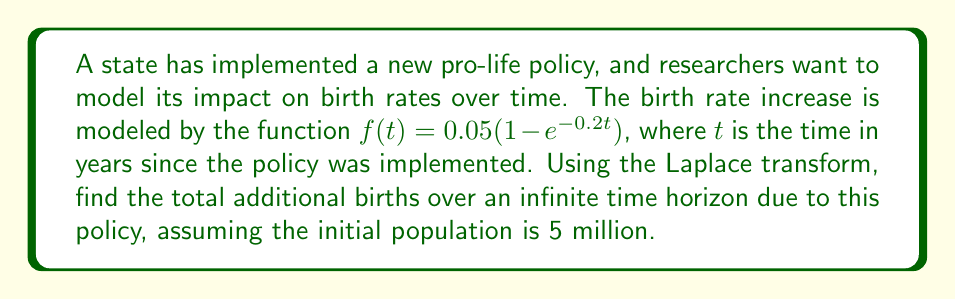Could you help me with this problem? To solve this problem, we'll follow these steps:

1) First, we need to find the Laplace transform of $f(t)$:

   $F(s) = \mathcal{L}\{f(t)\} = \mathcal{L}\{0.05(1 - e^{-0.2t})\}$

2) Using linearity and the standard Laplace transform for $e^{-at}$:

   $F(s) = 0.05(\frac{1}{s} - \frac{1}{s+0.2})$

3) To find the total additional births over an infinite time horizon, we need to evaluate $\lim_{s \to 0} sF(s)$:

   $\lim_{s \to 0} sF(s) = \lim_{s \to 0} 0.05s(\frac{1}{s} - \frac{1}{s+0.2})$

4) Simplifying:

   $\lim_{s \to 0} 0.05(\frac{s}{s} - \frac{s}{s+0.2}) = 0.05(1 - 0) = 0.05$

5) This result represents the proportion of additional births relative to the initial population. To get the actual number of additional births, we multiply by the initial population:

   $0.05 * 5,000,000 = 250,000$

Therefore, the model predicts that this pro-life policy will result in 250,000 additional births over an infinite time horizon.
Answer: 250,000 additional births 